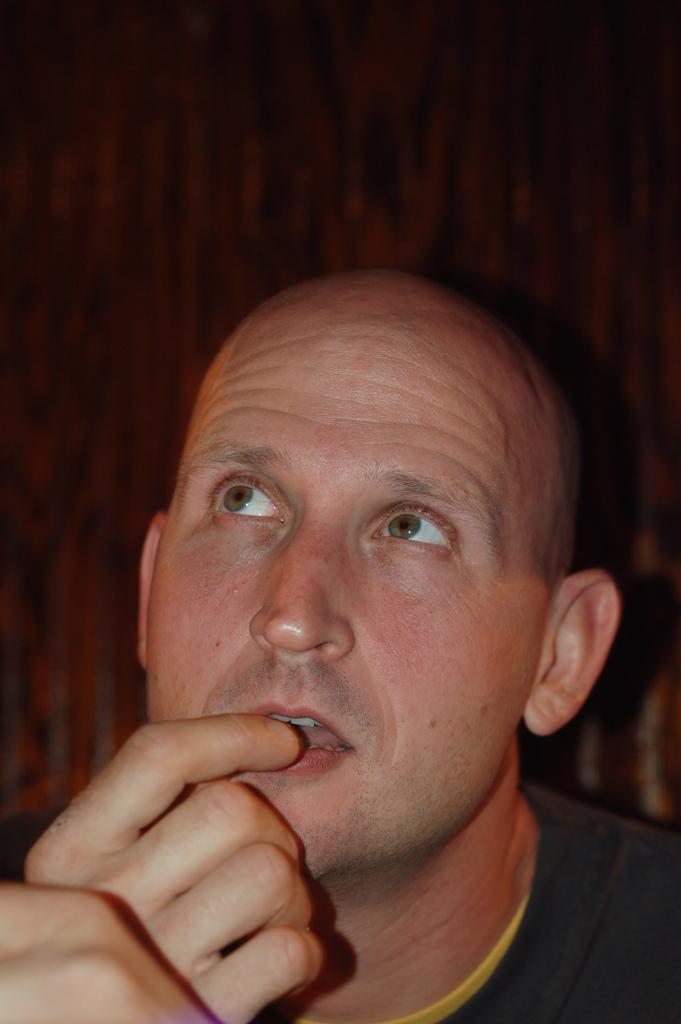Who is present in the image? There is a man in the image. Can you describe the background of the image? The background of the image is blurry. What type of produce is being burned by the committee in the image? There is no committee, produce, or burning depicted in the image; it only features a man with a blurry background. 